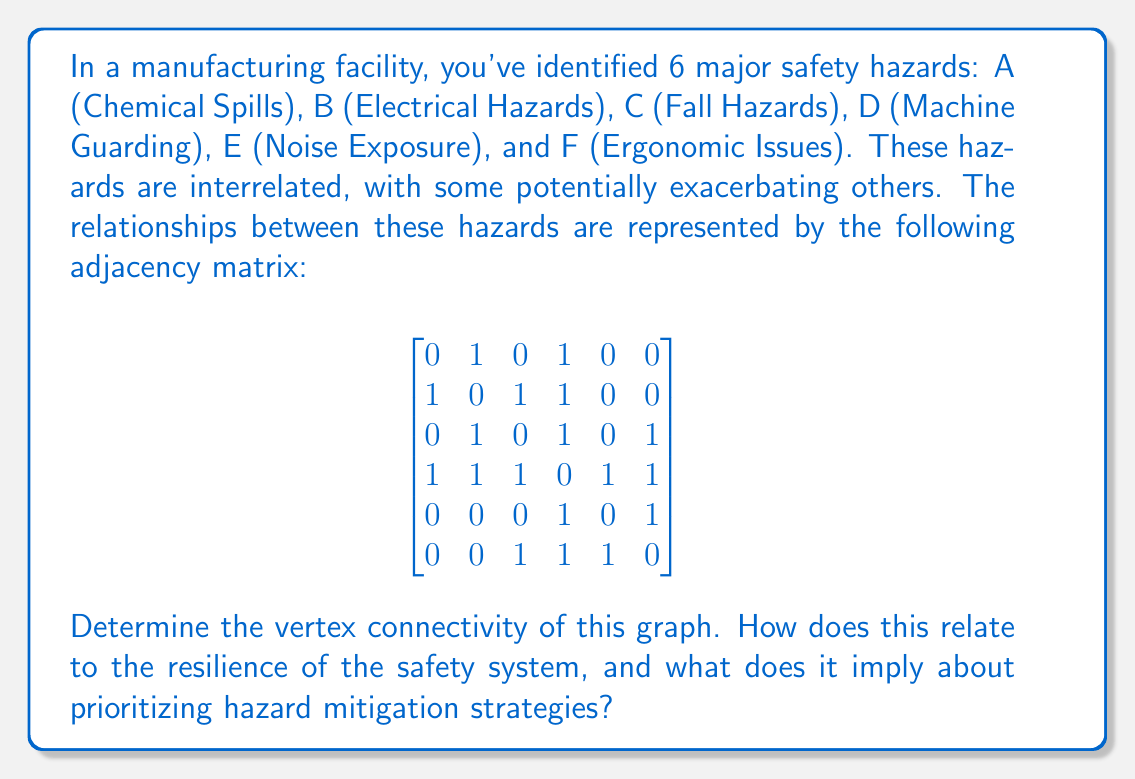Give your solution to this math problem. To solve this problem, we need to understand the concept of vertex connectivity and how to calculate it for the given graph. Then, we'll interpret its meaning in the context of occupational health and safety.

1) Vertex connectivity is defined as the minimum number of vertices that need to be removed to disconnect the graph.

2) To find the vertex connectivity, we need to identify the minimum vertex cut set. This is the smallest set of vertices whose removal would disconnect the graph.

3) Let's analyze the graph:
   - It has 6 vertices (A, B, C, D, E, F)
   - We can see that vertex D is connected to all other vertices
   - Removing D would not disconnect the graph, as other connections exist
   - We need to check if removing any two vertices would disconnect the graph

4) After careful examination, we find that removing vertices B and D disconnects the graph:
   - This leaves A isolated
   - C, E, and F remain connected

5) No single vertex removal can disconnect the graph, but removal of two specific vertices (B and D) does.

Therefore, the vertex connectivity of this graph is 2.

Interpreting this result in the context of occupational health and safety:

1) The vertex connectivity of 2 indicates that the safety hazard network is relatively robust. It takes the removal (or mitigation) of at least two hazards to completely break the network of interrelated risks.

2) This implies that the safety system has some built-in redundancy, which is generally positive for overall safety management.

3) However, it also highlights that hazards B (Electrical Hazards) and D (Machine Guarding) are critical points in the system. They form a minimum cut set, meaning they are key connectors in the hazard relationship network.

4) From a hazard mitigation perspective, this suggests that prioritizing efforts to address electrical hazards and improve machine guarding could have the most significant impact on reducing overall risk in the facility.

5) The analysis also reveals that these two hazards might have compounding effects on other risks, making them particularly important to monitor and control.

6) While addressing these key hazards is crucial, the interconnected nature of the hazards (as shown by the relatively high connectivity) suggests that a holistic approach to safety management is necessary, rather than focusing solely on individual hazards in isolation.
Answer: The vertex connectivity of the graph is 2. This indicates a moderately resilient safety system where electrical hazards and machine guarding are critical points. Prioritizing mitigation efforts on these two areas could significantly reduce overall risk, but a holistic approach to safety management is still necessary due to the interconnected nature of the hazards. 